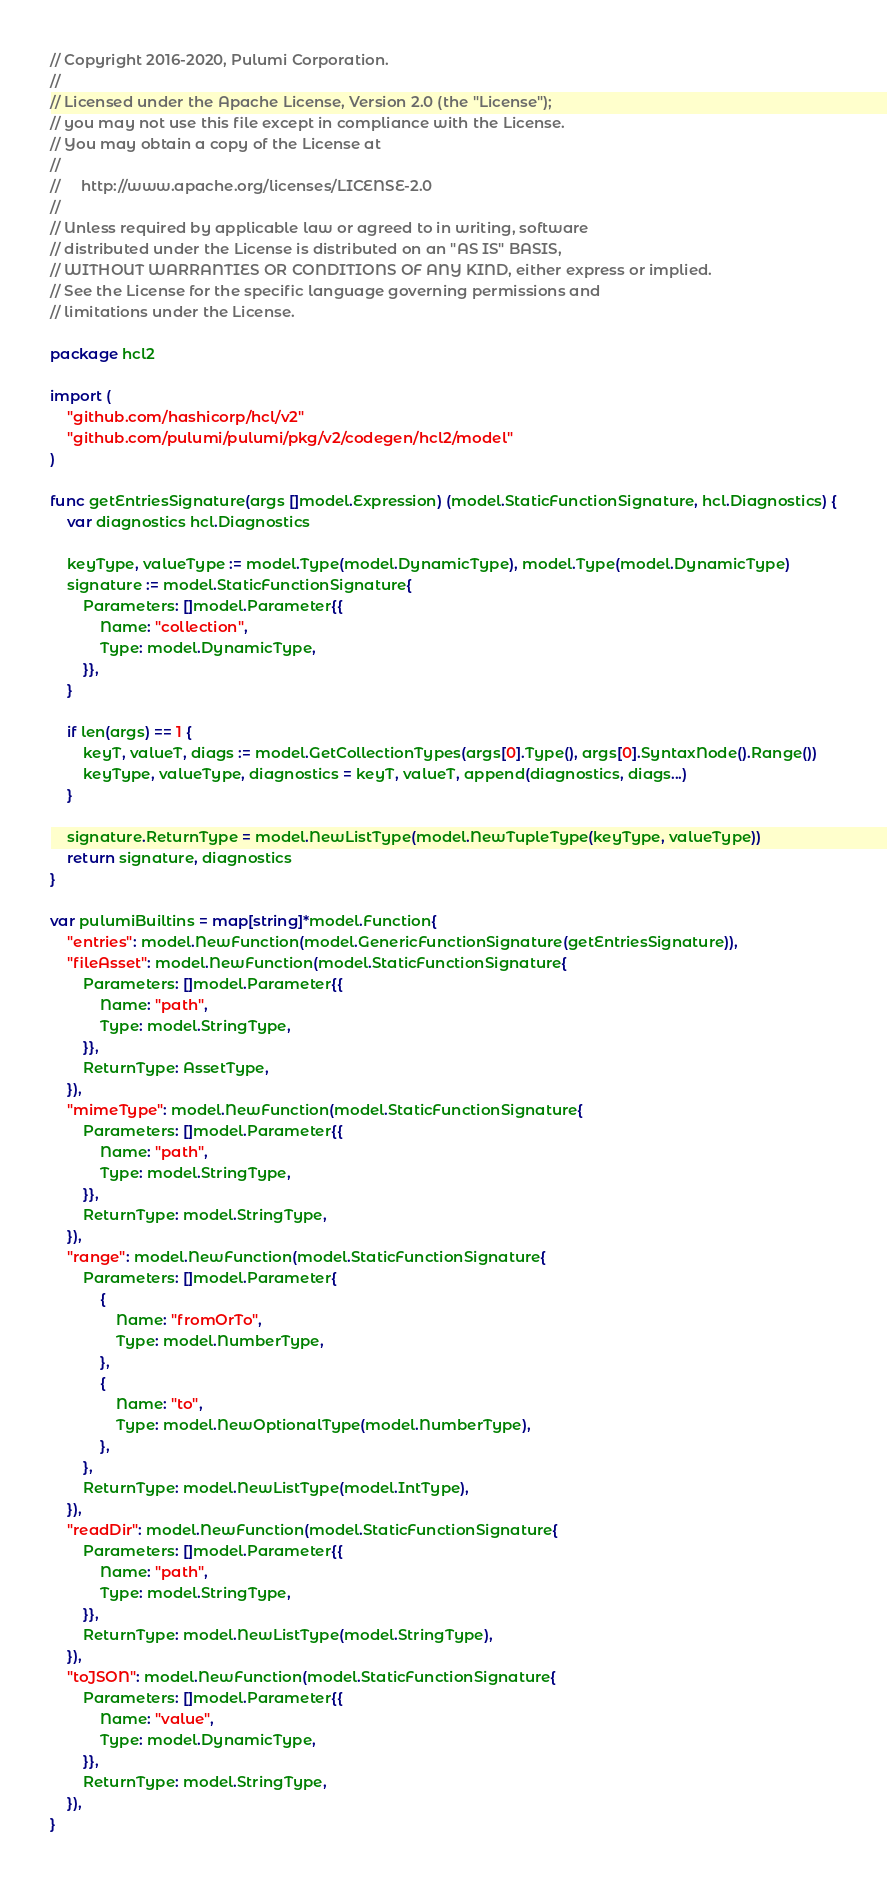<code> <loc_0><loc_0><loc_500><loc_500><_Go_>// Copyright 2016-2020, Pulumi Corporation.
//
// Licensed under the Apache License, Version 2.0 (the "License");
// you may not use this file except in compliance with the License.
// You may obtain a copy of the License at
//
//     http://www.apache.org/licenses/LICENSE-2.0
//
// Unless required by applicable law or agreed to in writing, software
// distributed under the License is distributed on an "AS IS" BASIS,
// WITHOUT WARRANTIES OR CONDITIONS OF ANY KIND, either express or implied.
// See the License for the specific language governing permissions and
// limitations under the License.

package hcl2

import (
	"github.com/hashicorp/hcl/v2"
	"github.com/pulumi/pulumi/pkg/v2/codegen/hcl2/model"
)

func getEntriesSignature(args []model.Expression) (model.StaticFunctionSignature, hcl.Diagnostics) {
	var diagnostics hcl.Diagnostics

	keyType, valueType := model.Type(model.DynamicType), model.Type(model.DynamicType)
	signature := model.StaticFunctionSignature{
		Parameters: []model.Parameter{{
			Name: "collection",
			Type: model.DynamicType,
		}},
	}

	if len(args) == 1 {
		keyT, valueT, diags := model.GetCollectionTypes(args[0].Type(), args[0].SyntaxNode().Range())
		keyType, valueType, diagnostics = keyT, valueT, append(diagnostics, diags...)
	}

	signature.ReturnType = model.NewListType(model.NewTupleType(keyType, valueType))
	return signature, diagnostics
}

var pulumiBuiltins = map[string]*model.Function{
	"entries": model.NewFunction(model.GenericFunctionSignature(getEntriesSignature)),
	"fileAsset": model.NewFunction(model.StaticFunctionSignature{
		Parameters: []model.Parameter{{
			Name: "path",
			Type: model.StringType,
		}},
		ReturnType: AssetType,
	}),
	"mimeType": model.NewFunction(model.StaticFunctionSignature{
		Parameters: []model.Parameter{{
			Name: "path",
			Type: model.StringType,
		}},
		ReturnType: model.StringType,
	}),
	"range": model.NewFunction(model.StaticFunctionSignature{
		Parameters: []model.Parameter{
			{
				Name: "fromOrTo",
				Type: model.NumberType,
			},
			{
				Name: "to",
				Type: model.NewOptionalType(model.NumberType),
			},
		},
		ReturnType: model.NewListType(model.IntType),
	}),
	"readDir": model.NewFunction(model.StaticFunctionSignature{
		Parameters: []model.Parameter{{
			Name: "path",
			Type: model.StringType,
		}},
		ReturnType: model.NewListType(model.StringType),
	}),
	"toJSON": model.NewFunction(model.StaticFunctionSignature{
		Parameters: []model.Parameter{{
			Name: "value",
			Type: model.DynamicType,
		}},
		ReturnType: model.StringType,
	}),
}
</code> 